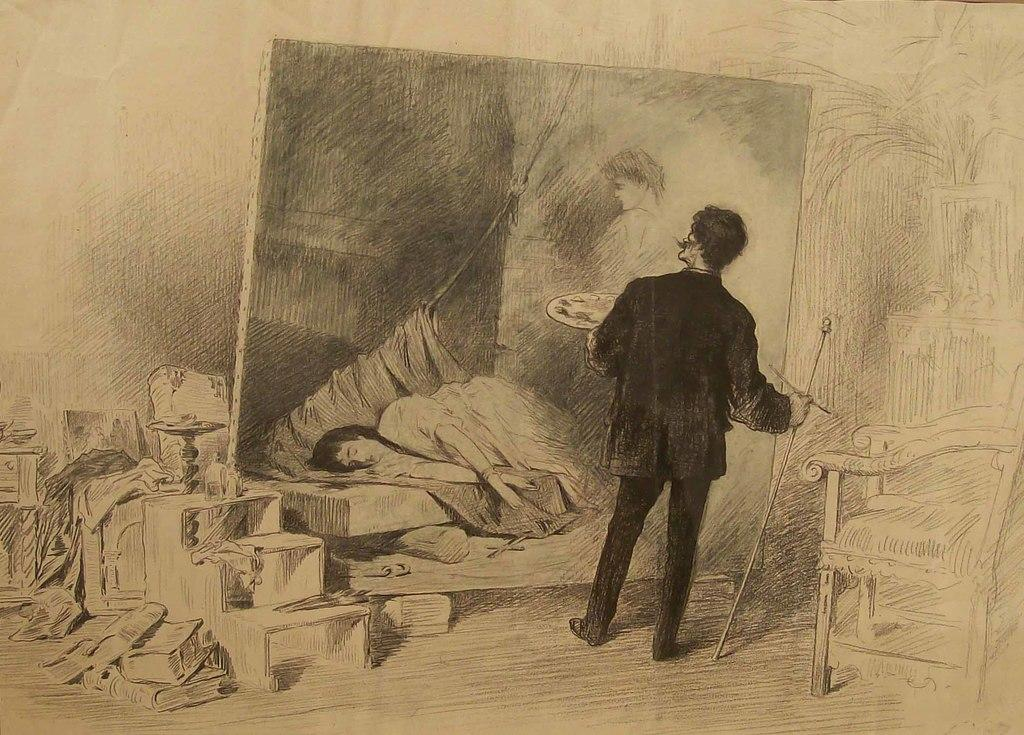What is the main subject of the art piece in the image? The art piece depicts a person holding objects. What type of surface can be seen in the image? There is ground visible in the image. What is present on the ground in the image? There are objects on the ground. What can be seen hanging on a wall or surface in the image? There is a board with a painting in the image. What type of furniture is visible in the image? There is a chair in the image. What type of plant is growing on the base of the committee in the image? There is no committee or plant present in the image. 